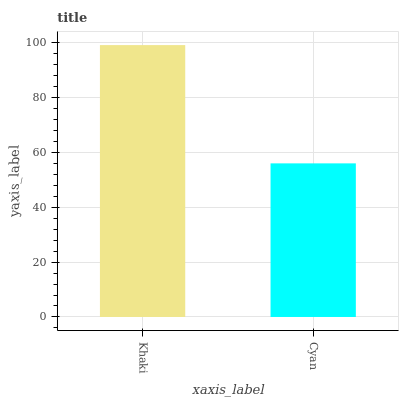Is Cyan the minimum?
Answer yes or no. Yes. Is Khaki the maximum?
Answer yes or no. Yes. Is Cyan the maximum?
Answer yes or no. No. Is Khaki greater than Cyan?
Answer yes or no. Yes. Is Cyan less than Khaki?
Answer yes or no. Yes. Is Cyan greater than Khaki?
Answer yes or no. No. Is Khaki less than Cyan?
Answer yes or no. No. Is Khaki the high median?
Answer yes or no. Yes. Is Cyan the low median?
Answer yes or no. Yes. Is Cyan the high median?
Answer yes or no. No. Is Khaki the low median?
Answer yes or no. No. 